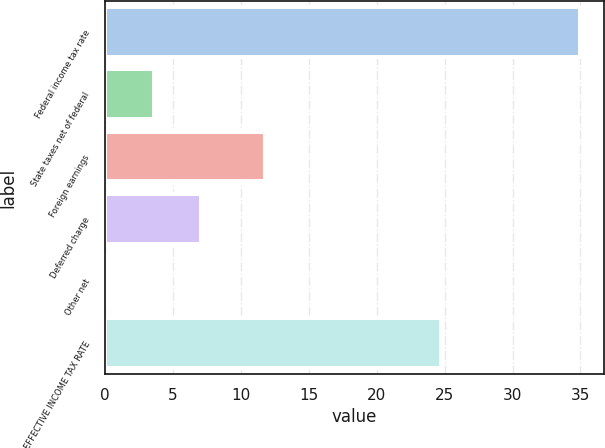Convert chart to OTSL. <chart><loc_0><loc_0><loc_500><loc_500><bar_chart><fcel>Federal income tax rate<fcel>State taxes net of federal<fcel>Foreign earnings<fcel>Deferred charge<fcel>Other net<fcel>EFFECTIVE INCOME TAX RATE<nl><fcel>35<fcel>3.59<fcel>11.8<fcel>7.08<fcel>0.1<fcel>24.7<nl></chart> 